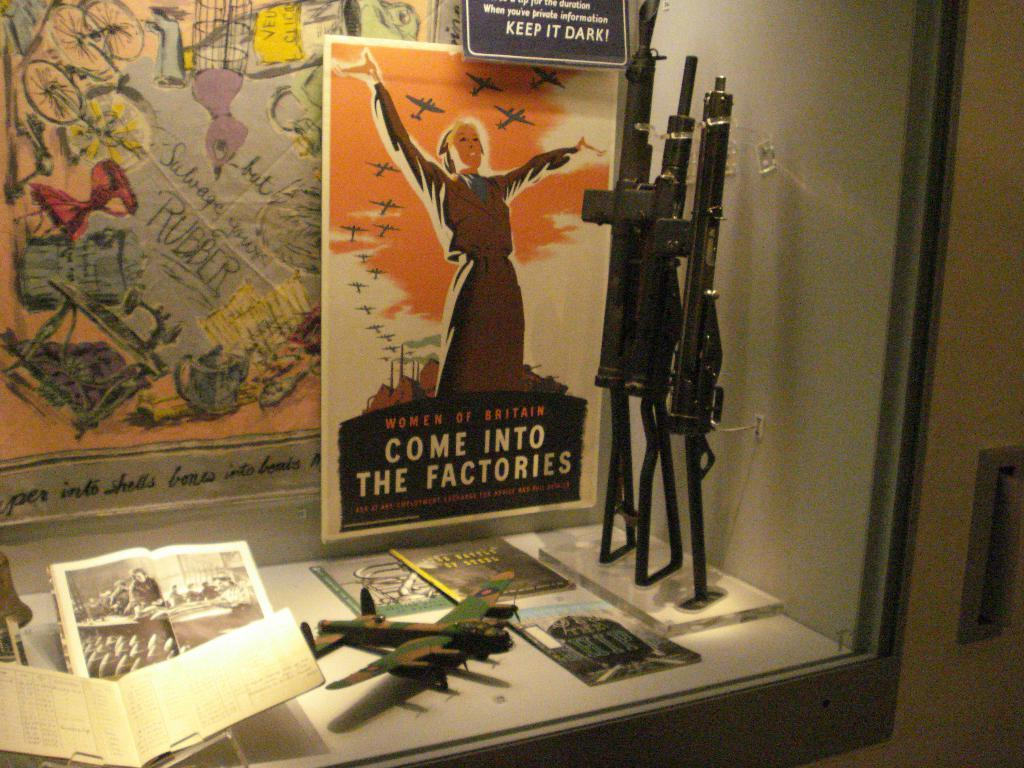<image>
Create a compact narrative representing the image presented. A display with a small airplane and posters behind it one saying Come Into The Factories. 